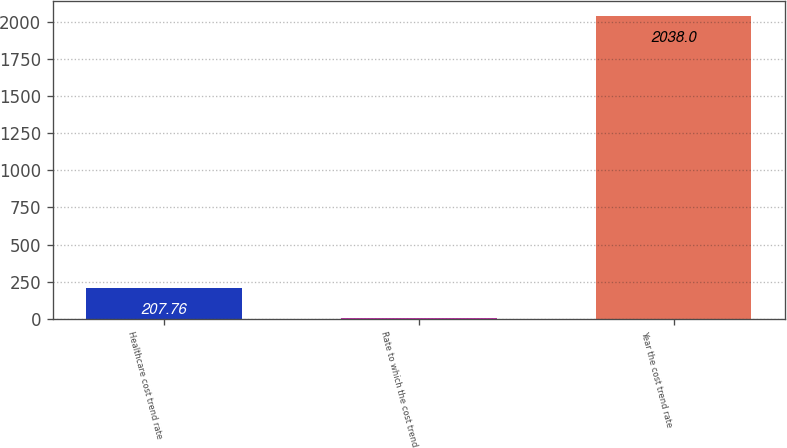Convert chart to OTSL. <chart><loc_0><loc_0><loc_500><loc_500><bar_chart><fcel>Healthcare cost trend rate<fcel>Rate to which the cost trend<fcel>Year the cost trend rate<nl><fcel>207.76<fcel>4.4<fcel>2038<nl></chart> 